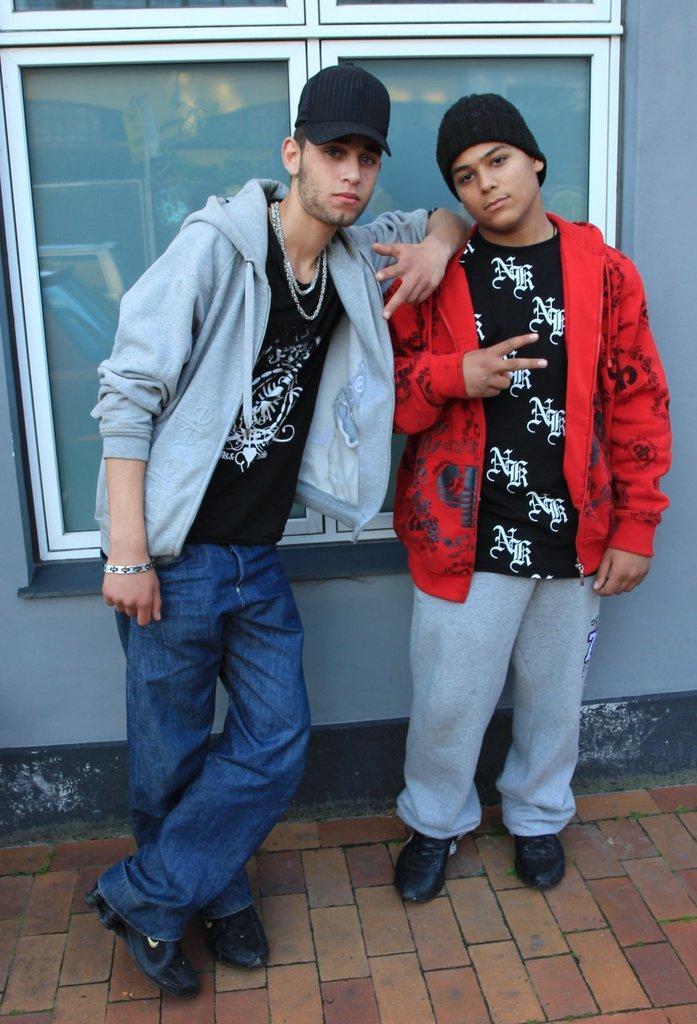Please provide a concise description of this image. This image consists of two persons. On the left, the man is wearing a jacket. On the right, the man is wearing a red jacket. At the bottom, there is a road. In the background, we can see a window along with a wall. 